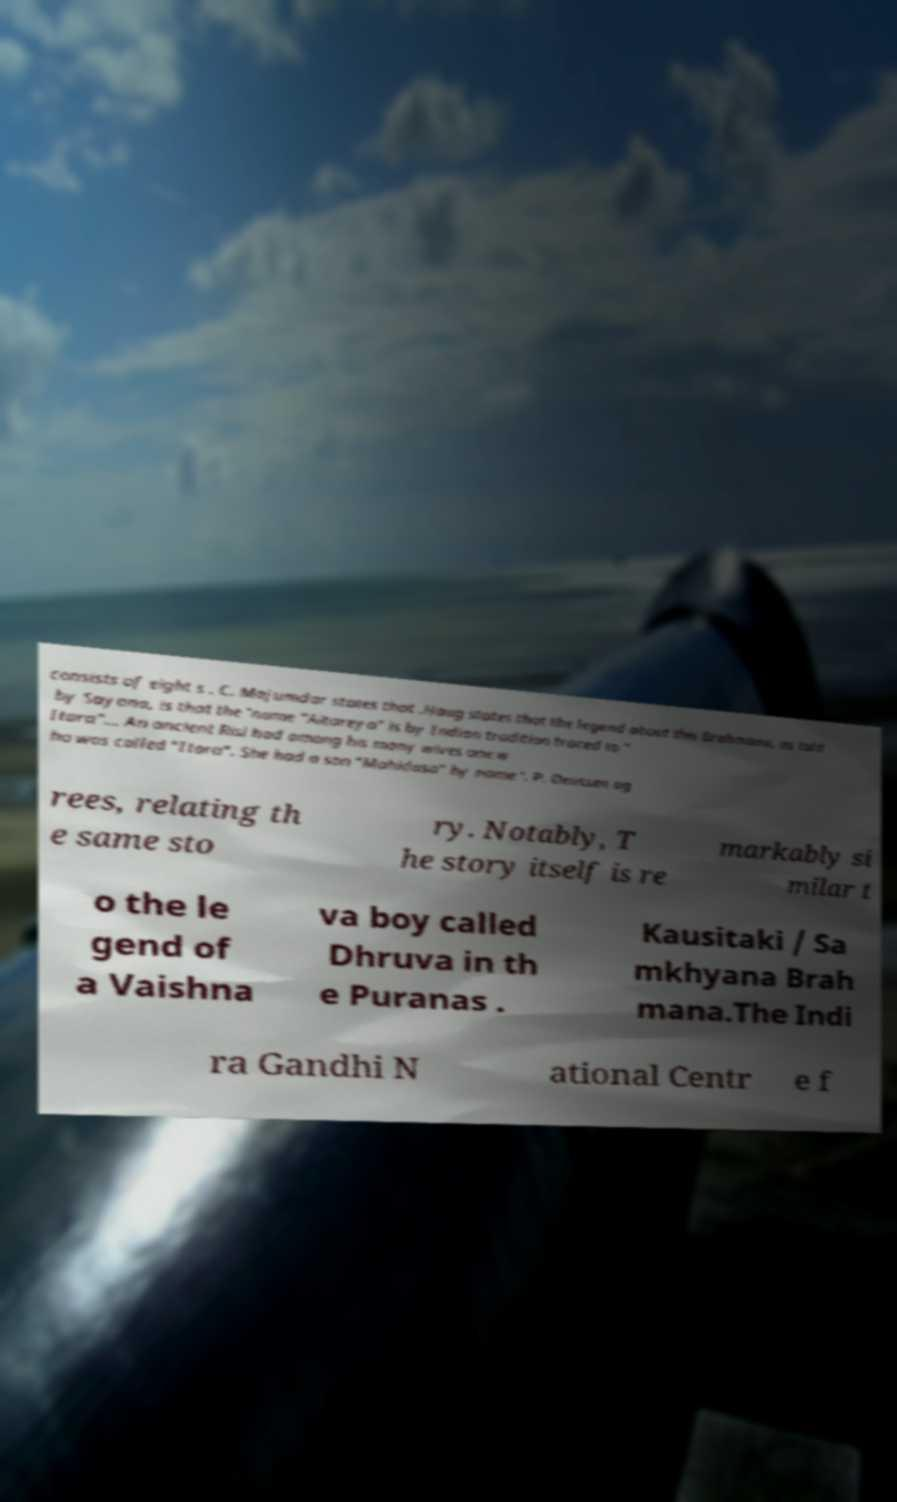Could you assist in decoding the text presented in this image and type it out clearly? consists of eight s . C. Majumdar states that .Haug states that the legend about this Brahmana, as told by Sayana, is that the 'name "Aitareya" is by Indian tradition traced to " Itara"... An ancient Risi had among his many wives one w ho was called "Itara". She had a son "Mahidasa" by name '. P. Deussen ag rees, relating th e same sto ry. Notably, T he story itself is re markably si milar t o the le gend of a Vaishna va boy called Dhruva in th e Puranas . Kausitaki / Sa mkhyana Brah mana.The Indi ra Gandhi N ational Centr e f 